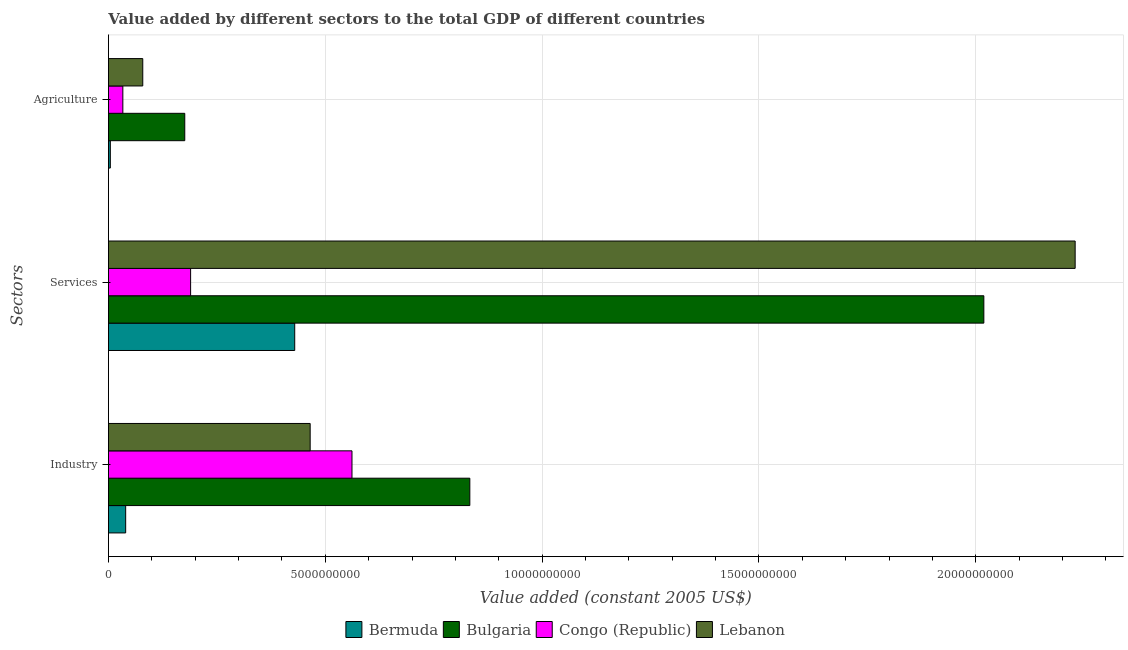How many different coloured bars are there?
Make the answer very short. 4. How many groups of bars are there?
Provide a succinct answer. 3. Are the number of bars on each tick of the Y-axis equal?
Make the answer very short. Yes. What is the label of the 1st group of bars from the top?
Provide a succinct answer. Agriculture. What is the value added by agricultural sector in Congo (Republic)?
Your answer should be compact. 3.32e+08. Across all countries, what is the maximum value added by industrial sector?
Offer a terse response. 8.33e+09. Across all countries, what is the minimum value added by services?
Keep it short and to the point. 1.89e+09. In which country was the value added by services maximum?
Make the answer very short. Lebanon. In which country was the value added by industrial sector minimum?
Provide a succinct answer. Bermuda. What is the total value added by services in the graph?
Give a very brief answer. 4.87e+1. What is the difference between the value added by services in Congo (Republic) and that in Bermuda?
Your answer should be compact. -2.40e+09. What is the difference between the value added by agricultural sector in Congo (Republic) and the value added by services in Lebanon?
Your response must be concise. -2.20e+1. What is the average value added by industrial sector per country?
Provide a short and direct response. 4.75e+09. What is the difference between the value added by agricultural sector and value added by services in Lebanon?
Your answer should be very brief. -2.15e+1. What is the ratio of the value added by agricultural sector in Congo (Republic) to that in Lebanon?
Your answer should be very brief. 0.42. Is the value added by industrial sector in Bermuda less than that in Lebanon?
Offer a terse response. Yes. What is the difference between the highest and the second highest value added by agricultural sector?
Give a very brief answer. 9.68e+08. What is the difference between the highest and the lowest value added by agricultural sector?
Your response must be concise. 1.72e+09. Is the sum of the value added by agricultural sector in Bermuda and Lebanon greater than the maximum value added by services across all countries?
Offer a terse response. No. What does the 3rd bar from the top in Agriculture represents?
Give a very brief answer. Bulgaria. What does the 4th bar from the bottom in Industry represents?
Your response must be concise. Lebanon. Is it the case that in every country, the sum of the value added by industrial sector and value added by services is greater than the value added by agricultural sector?
Your answer should be compact. Yes. How many bars are there?
Make the answer very short. 12. How many countries are there in the graph?
Your response must be concise. 4. Does the graph contain any zero values?
Keep it short and to the point. No. Does the graph contain grids?
Offer a very short reply. Yes. How many legend labels are there?
Your answer should be very brief. 4. How are the legend labels stacked?
Offer a terse response. Horizontal. What is the title of the graph?
Give a very brief answer. Value added by different sectors to the total GDP of different countries. What is the label or title of the X-axis?
Ensure brevity in your answer.  Value added (constant 2005 US$). What is the label or title of the Y-axis?
Ensure brevity in your answer.  Sectors. What is the Value added (constant 2005 US$) in Bermuda in Industry?
Provide a succinct answer. 3.98e+08. What is the Value added (constant 2005 US$) in Bulgaria in Industry?
Offer a terse response. 8.33e+09. What is the Value added (constant 2005 US$) of Congo (Republic) in Industry?
Your response must be concise. 5.62e+09. What is the Value added (constant 2005 US$) of Lebanon in Industry?
Keep it short and to the point. 4.65e+09. What is the Value added (constant 2005 US$) of Bermuda in Services?
Your response must be concise. 4.30e+09. What is the Value added (constant 2005 US$) of Bulgaria in Services?
Provide a succinct answer. 2.02e+1. What is the Value added (constant 2005 US$) of Congo (Republic) in Services?
Make the answer very short. 1.89e+09. What is the Value added (constant 2005 US$) of Lebanon in Services?
Give a very brief answer. 2.23e+1. What is the Value added (constant 2005 US$) of Bermuda in Agriculture?
Your response must be concise. 4.38e+07. What is the Value added (constant 2005 US$) of Bulgaria in Agriculture?
Offer a very short reply. 1.76e+09. What is the Value added (constant 2005 US$) in Congo (Republic) in Agriculture?
Offer a terse response. 3.32e+08. What is the Value added (constant 2005 US$) in Lebanon in Agriculture?
Provide a succinct answer. 7.92e+08. Across all Sectors, what is the maximum Value added (constant 2005 US$) in Bermuda?
Make the answer very short. 4.30e+09. Across all Sectors, what is the maximum Value added (constant 2005 US$) of Bulgaria?
Your answer should be compact. 2.02e+1. Across all Sectors, what is the maximum Value added (constant 2005 US$) in Congo (Republic)?
Provide a succinct answer. 5.62e+09. Across all Sectors, what is the maximum Value added (constant 2005 US$) of Lebanon?
Your response must be concise. 2.23e+1. Across all Sectors, what is the minimum Value added (constant 2005 US$) of Bermuda?
Make the answer very short. 4.38e+07. Across all Sectors, what is the minimum Value added (constant 2005 US$) in Bulgaria?
Provide a short and direct response. 1.76e+09. Across all Sectors, what is the minimum Value added (constant 2005 US$) in Congo (Republic)?
Ensure brevity in your answer.  3.32e+08. Across all Sectors, what is the minimum Value added (constant 2005 US$) of Lebanon?
Provide a short and direct response. 7.92e+08. What is the total Value added (constant 2005 US$) in Bermuda in the graph?
Ensure brevity in your answer.  4.74e+09. What is the total Value added (constant 2005 US$) in Bulgaria in the graph?
Give a very brief answer. 3.03e+1. What is the total Value added (constant 2005 US$) in Congo (Republic) in the graph?
Your answer should be compact. 7.84e+09. What is the total Value added (constant 2005 US$) in Lebanon in the graph?
Provide a succinct answer. 2.77e+1. What is the difference between the Value added (constant 2005 US$) of Bermuda in Industry and that in Services?
Provide a short and direct response. -3.90e+09. What is the difference between the Value added (constant 2005 US$) in Bulgaria in Industry and that in Services?
Make the answer very short. -1.19e+1. What is the difference between the Value added (constant 2005 US$) in Congo (Republic) in Industry and that in Services?
Your response must be concise. 3.72e+09. What is the difference between the Value added (constant 2005 US$) of Lebanon in Industry and that in Services?
Offer a very short reply. -1.76e+1. What is the difference between the Value added (constant 2005 US$) in Bermuda in Industry and that in Agriculture?
Your answer should be compact. 3.54e+08. What is the difference between the Value added (constant 2005 US$) of Bulgaria in Industry and that in Agriculture?
Offer a terse response. 6.57e+09. What is the difference between the Value added (constant 2005 US$) in Congo (Republic) in Industry and that in Agriculture?
Ensure brevity in your answer.  5.28e+09. What is the difference between the Value added (constant 2005 US$) in Lebanon in Industry and that in Agriculture?
Offer a very short reply. 3.86e+09. What is the difference between the Value added (constant 2005 US$) of Bermuda in Services and that in Agriculture?
Your answer should be very brief. 4.25e+09. What is the difference between the Value added (constant 2005 US$) of Bulgaria in Services and that in Agriculture?
Ensure brevity in your answer.  1.84e+1. What is the difference between the Value added (constant 2005 US$) of Congo (Republic) in Services and that in Agriculture?
Your response must be concise. 1.56e+09. What is the difference between the Value added (constant 2005 US$) of Lebanon in Services and that in Agriculture?
Offer a terse response. 2.15e+1. What is the difference between the Value added (constant 2005 US$) of Bermuda in Industry and the Value added (constant 2005 US$) of Bulgaria in Services?
Ensure brevity in your answer.  -1.98e+1. What is the difference between the Value added (constant 2005 US$) of Bermuda in Industry and the Value added (constant 2005 US$) of Congo (Republic) in Services?
Make the answer very short. -1.50e+09. What is the difference between the Value added (constant 2005 US$) in Bermuda in Industry and the Value added (constant 2005 US$) in Lebanon in Services?
Ensure brevity in your answer.  -2.19e+1. What is the difference between the Value added (constant 2005 US$) of Bulgaria in Industry and the Value added (constant 2005 US$) of Congo (Republic) in Services?
Ensure brevity in your answer.  6.44e+09. What is the difference between the Value added (constant 2005 US$) in Bulgaria in Industry and the Value added (constant 2005 US$) in Lebanon in Services?
Ensure brevity in your answer.  -1.40e+1. What is the difference between the Value added (constant 2005 US$) in Congo (Republic) in Industry and the Value added (constant 2005 US$) in Lebanon in Services?
Provide a short and direct response. -1.67e+1. What is the difference between the Value added (constant 2005 US$) in Bermuda in Industry and the Value added (constant 2005 US$) in Bulgaria in Agriculture?
Your answer should be very brief. -1.36e+09. What is the difference between the Value added (constant 2005 US$) of Bermuda in Industry and the Value added (constant 2005 US$) of Congo (Republic) in Agriculture?
Make the answer very short. 6.51e+07. What is the difference between the Value added (constant 2005 US$) in Bermuda in Industry and the Value added (constant 2005 US$) in Lebanon in Agriculture?
Your response must be concise. -3.94e+08. What is the difference between the Value added (constant 2005 US$) in Bulgaria in Industry and the Value added (constant 2005 US$) in Congo (Republic) in Agriculture?
Offer a very short reply. 8.00e+09. What is the difference between the Value added (constant 2005 US$) of Bulgaria in Industry and the Value added (constant 2005 US$) of Lebanon in Agriculture?
Keep it short and to the point. 7.54e+09. What is the difference between the Value added (constant 2005 US$) of Congo (Republic) in Industry and the Value added (constant 2005 US$) of Lebanon in Agriculture?
Offer a very short reply. 4.82e+09. What is the difference between the Value added (constant 2005 US$) in Bermuda in Services and the Value added (constant 2005 US$) in Bulgaria in Agriculture?
Keep it short and to the point. 2.54e+09. What is the difference between the Value added (constant 2005 US$) of Bermuda in Services and the Value added (constant 2005 US$) of Congo (Republic) in Agriculture?
Provide a short and direct response. 3.96e+09. What is the difference between the Value added (constant 2005 US$) in Bermuda in Services and the Value added (constant 2005 US$) in Lebanon in Agriculture?
Your response must be concise. 3.50e+09. What is the difference between the Value added (constant 2005 US$) in Bulgaria in Services and the Value added (constant 2005 US$) in Congo (Republic) in Agriculture?
Provide a short and direct response. 1.99e+1. What is the difference between the Value added (constant 2005 US$) of Bulgaria in Services and the Value added (constant 2005 US$) of Lebanon in Agriculture?
Keep it short and to the point. 1.94e+1. What is the difference between the Value added (constant 2005 US$) of Congo (Republic) in Services and the Value added (constant 2005 US$) of Lebanon in Agriculture?
Your response must be concise. 1.10e+09. What is the average Value added (constant 2005 US$) in Bermuda per Sectors?
Your response must be concise. 1.58e+09. What is the average Value added (constant 2005 US$) of Bulgaria per Sectors?
Provide a succinct answer. 1.01e+1. What is the average Value added (constant 2005 US$) of Congo (Republic) per Sectors?
Make the answer very short. 2.61e+09. What is the average Value added (constant 2005 US$) of Lebanon per Sectors?
Keep it short and to the point. 9.24e+09. What is the difference between the Value added (constant 2005 US$) of Bermuda and Value added (constant 2005 US$) of Bulgaria in Industry?
Provide a succinct answer. -7.94e+09. What is the difference between the Value added (constant 2005 US$) in Bermuda and Value added (constant 2005 US$) in Congo (Republic) in Industry?
Provide a succinct answer. -5.22e+09. What is the difference between the Value added (constant 2005 US$) of Bermuda and Value added (constant 2005 US$) of Lebanon in Industry?
Ensure brevity in your answer.  -4.25e+09. What is the difference between the Value added (constant 2005 US$) of Bulgaria and Value added (constant 2005 US$) of Congo (Republic) in Industry?
Provide a succinct answer. 2.72e+09. What is the difference between the Value added (constant 2005 US$) in Bulgaria and Value added (constant 2005 US$) in Lebanon in Industry?
Offer a terse response. 3.68e+09. What is the difference between the Value added (constant 2005 US$) of Congo (Republic) and Value added (constant 2005 US$) of Lebanon in Industry?
Your answer should be very brief. 9.64e+08. What is the difference between the Value added (constant 2005 US$) in Bermuda and Value added (constant 2005 US$) in Bulgaria in Services?
Give a very brief answer. -1.59e+1. What is the difference between the Value added (constant 2005 US$) in Bermuda and Value added (constant 2005 US$) in Congo (Republic) in Services?
Offer a terse response. 2.40e+09. What is the difference between the Value added (constant 2005 US$) in Bermuda and Value added (constant 2005 US$) in Lebanon in Services?
Provide a short and direct response. -1.80e+1. What is the difference between the Value added (constant 2005 US$) in Bulgaria and Value added (constant 2005 US$) in Congo (Republic) in Services?
Your answer should be compact. 1.83e+1. What is the difference between the Value added (constant 2005 US$) in Bulgaria and Value added (constant 2005 US$) in Lebanon in Services?
Your response must be concise. -2.11e+09. What is the difference between the Value added (constant 2005 US$) in Congo (Republic) and Value added (constant 2005 US$) in Lebanon in Services?
Ensure brevity in your answer.  -2.04e+1. What is the difference between the Value added (constant 2005 US$) of Bermuda and Value added (constant 2005 US$) of Bulgaria in Agriculture?
Ensure brevity in your answer.  -1.72e+09. What is the difference between the Value added (constant 2005 US$) in Bermuda and Value added (constant 2005 US$) in Congo (Republic) in Agriculture?
Provide a short and direct response. -2.89e+08. What is the difference between the Value added (constant 2005 US$) in Bermuda and Value added (constant 2005 US$) in Lebanon in Agriculture?
Offer a very short reply. -7.48e+08. What is the difference between the Value added (constant 2005 US$) in Bulgaria and Value added (constant 2005 US$) in Congo (Republic) in Agriculture?
Provide a succinct answer. 1.43e+09. What is the difference between the Value added (constant 2005 US$) in Bulgaria and Value added (constant 2005 US$) in Lebanon in Agriculture?
Your answer should be very brief. 9.68e+08. What is the difference between the Value added (constant 2005 US$) of Congo (Republic) and Value added (constant 2005 US$) of Lebanon in Agriculture?
Keep it short and to the point. -4.59e+08. What is the ratio of the Value added (constant 2005 US$) in Bermuda in Industry to that in Services?
Provide a short and direct response. 0.09. What is the ratio of the Value added (constant 2005 US$) of Bulgaria in Industry to that in Services?
Give a very brief answer. 0.41. What is the ratio of the Value added (constant 2005 US$) of Congo (Republic) in Industry to that in Services?
Offer a very short reply. 2.96. What is the ratio of the Value added (constant 2005 US$) of Lebanon in Industry to that in Services?
Provide a short and direct response. 0.21. What is the ratio of the Value added (constant 2005 US$) in Bermuda in Industry to that in Agriculture?
Your answer should be compact. 9.07. What is the ratio of the Value added (constant 2005 US$) of Bulgaria in Industry to that in Agriculture?
Your answer should be compact. 4.73. What is the ratio of the Value added (constant 2005 US$) of Congo (Republic) in Industry to that in Agriculture?
Offer a very short reply. 16.89. What is the ratio of the Value added (constant 2005 US$) in Lebanon in Industry to that in Agriculture?
Provide a short and direct response. 5.88. What is the ratio of the Value added (constant 2005 US$) of Bermuda in Services to that in Agriculture?
Give a very brief answer. 98.02. What is the ratio of the Value added (constant 2005 US$) in Bulgaria in Services to that in Agriculture?
Your answer should be compact. 11.47. What is the ratio of the Value added (constant 2005 US$) in Congo (Republic) in Services to that in Agriculture?
Ensure brevity in your answer.  5.7. What is the ratio of the Value added (constant 2005 US$) in Lebanon in Services to that in Agriculture?
Make the answer very short. 28.16. What is the difference between the highest and the second highest Value added (constant 2005 US$) in Bermuda?
Offer a terse response. 3.90e+09. What is the difference between the highest and the second highest Value added (constant 2005 US$) in Bulgaria?
Your answer should be very brief. 1.19e+1. What is the difference between the highest and the second highest Value added (constant 2005 US$) in Congo (Republic)?
Provide a short and direct response. 3.72e+09. What is the difference between the highest and the second highest Value added (constant 2005 US$) in Lebanon?
Offer a terse response. 1.76e+1. What is the difference between the highest and the lowest Value added (constant 2005 US$) in Bermuda?
Give a very brief answer. 4.25e+09. What is the difference between the highest and the lowest Value added (constant 2005 US$) of Bulgaria?
Your answer should be very brief. 1.84e+1. What is the difference between the highest and the lowest Value added (constant 2005 US$) of Congo (Republic)?
Offer a very short reply. 5.28e+09. What is the difference between the highest and the lowest Value added (constant 2005 US$) of Lebanon?
Provide a short and direct response. 2.15e+1. 